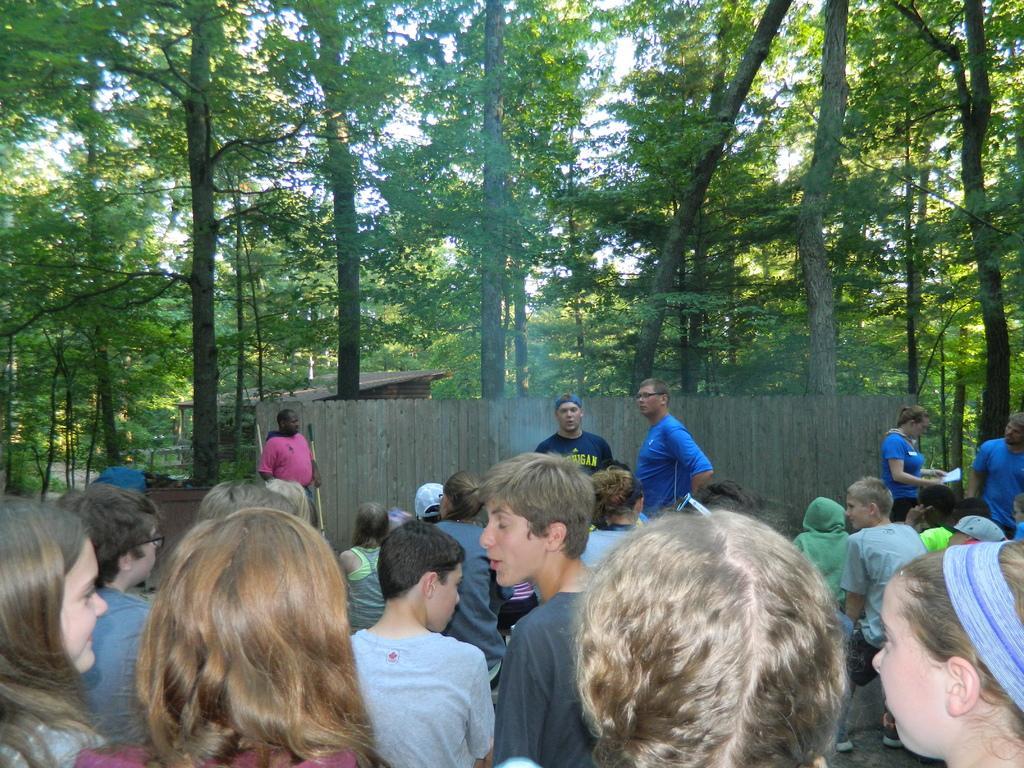Describe this image in one or two sentences. In this image, we can see people and some are holding objects in their hands. In the background, there are sheds and we can see trees and some other objects. 